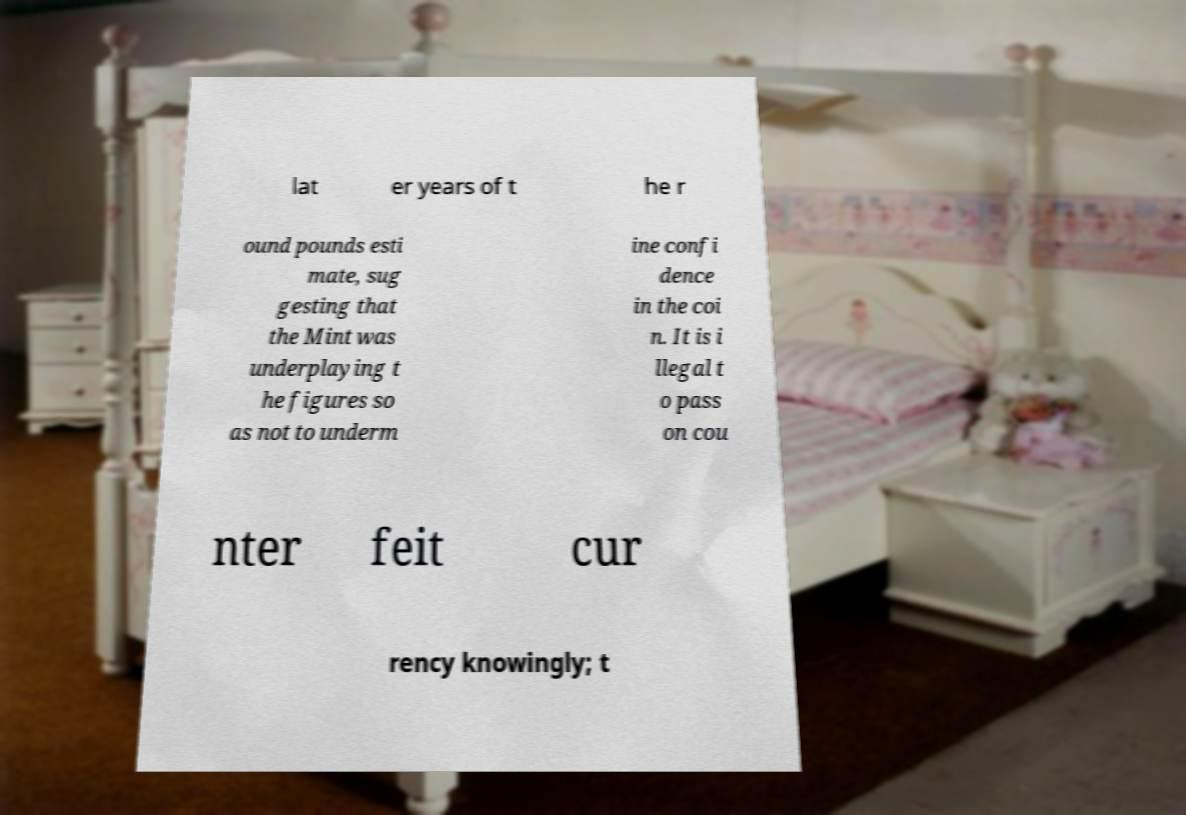I need the written content from this picture converted into text. Can you do that? lat er years of t he r ound pounds esti mate, sug gesting that the Mint was underplaying t he figures so as not to underm ine confi dence in the coi n. It is i llegal t o pass on cou nter feit cur rency knowingly; t 